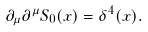<formula> <loc_0><loc_0><loc_500><loc_500>\partial _ { \mu } \partial ^ { \mu } S _ { 0 } ( x ) = \delta ^ { 4 } ( x ) .</formula> 